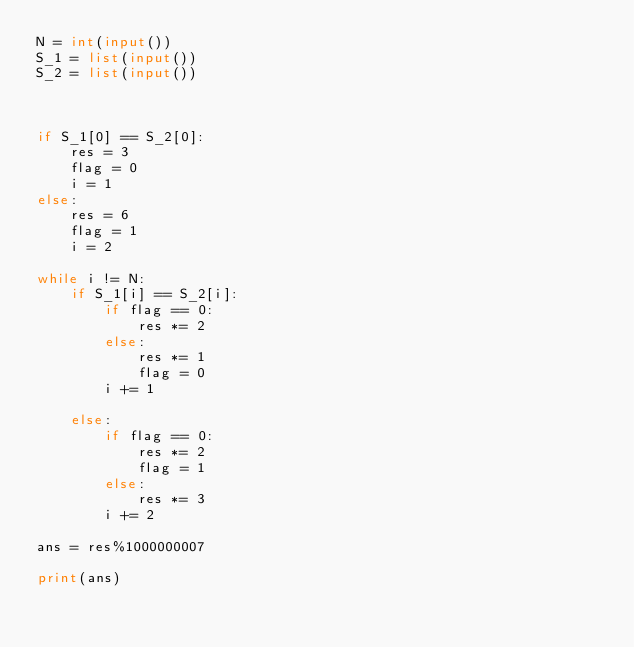Convert code to text. <code><loc_0><loc_0><loc_500><loc_500><_Python_>N = int(input())
S_1 = list(input())
S_2 = list(input())



if S_1[0] == S_2[0]:
    res = 3
    flag = 0
    i = 1
else:
    res = 6
    flag = 1
    i = 2

while i != N:
    if S_1[i] == S_2[i]:
        if flag == 0:
            res *= 2 
        else:
            res *= 1
            flag = 0
        i += 1

    else:
        if flag == 0:
            res *= 2
            flag = 1
        else:
            res *= 3
        i += 2
        
ans = res%1000000007

print(ans)
    </code> 